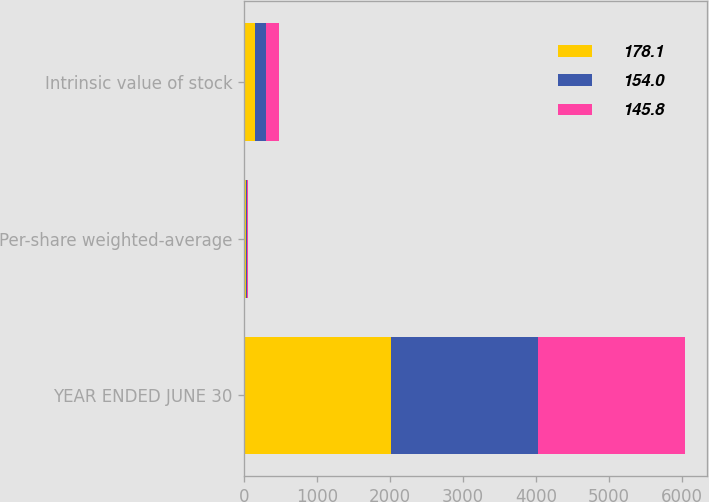Convert chart. <chart><loc_0><loc_0><loc_500><loc_500><stacked_bar_chart><ecel><fcel>YEAR ENDED JUNE 30<fcel>Per-share weighted-average<fcel>Intrinsic value of stock<nl><fcel>178.1<fcel>2013<fcel>20.3<fcel>145.8<nl><fcel>154<fcel>2012<fcel>17.41<fcel>154<nl><fcel>145.8<fcel>2011<fcel>18.93<fcel>178.1<nl></chart> 